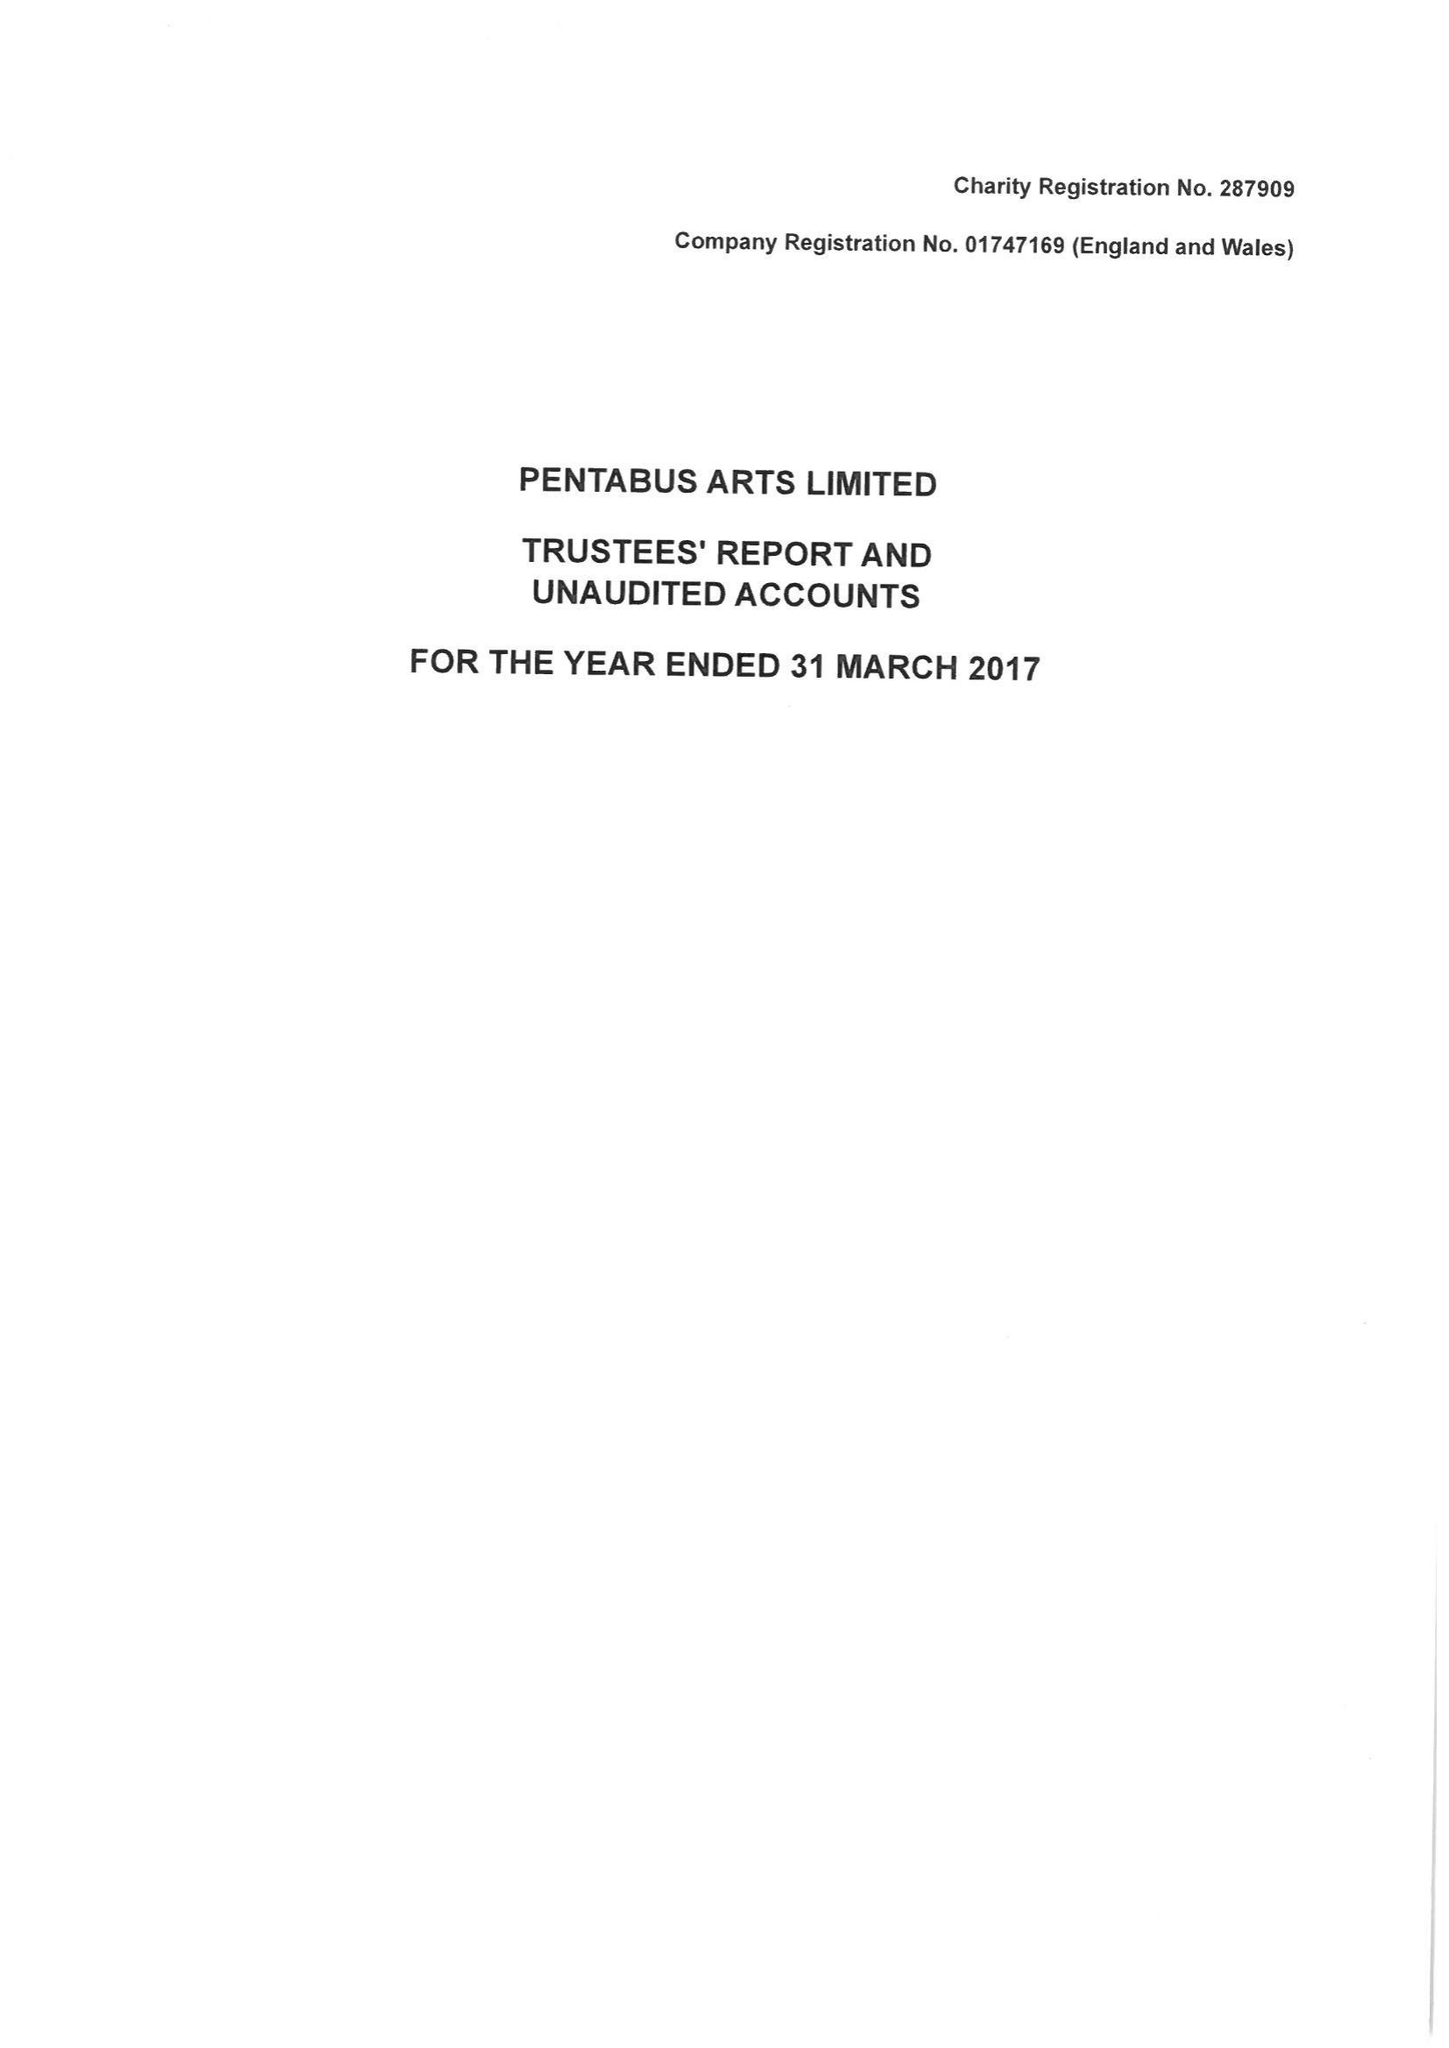What is the value for the address__postcode?
Answer the question using a single word or phrase. SY8 2JU 